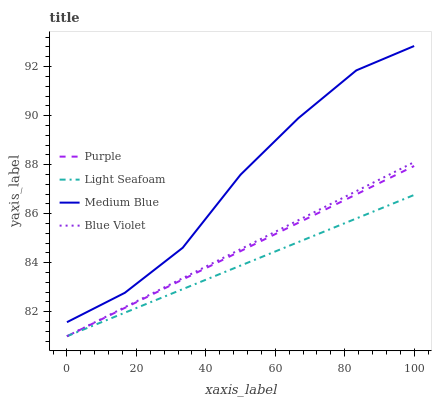Does Light Seafoam have the minimum area under the curve?
Answer yes or no. Yes. Does Medium Blue have the maximum area under the curve?
Answer yes or no. Yes. Does Medium Blue have the minimum area under the curve?
Answer yes or no. No. Does Light Seafoam have the maximum area under the curve?
Answer yes or no. No. Is Blue Violet the smoothest?
Answer yes or no. Yes. Is Medium Blue the roughest?
Answer yes or no. Yes. Is Light Seafoam the smoothest?
Answer yes or no. No. Is Light Seafoam the roughest?
Answer yes or no. No. Does Purple have the lowest value?
Answer yes or no. Yes. Does Medium Blue have the lowest value?
Answer yes or no. No. Does Medium Blue have the highest value?
Answer yes or no. Yes. Does Light Seafoam have the highest value?
Answer yes or no. No. Is Light Seafoam less than Medium Blue?
Answer yes or no. Yes. Is Medium Blue greater than Purple?
Answer yes or no. Yes. Does Light Seafoam intersect Purple?
Answer yes or no. Yes. Is Light Seafoam less than Purple?
Answer yes or no. No. Is Light Seafoam greater than Purple?
Answer yes or no. No. Does Light Seafoam intersect Medium Blue?
Answer yes or no. No. 